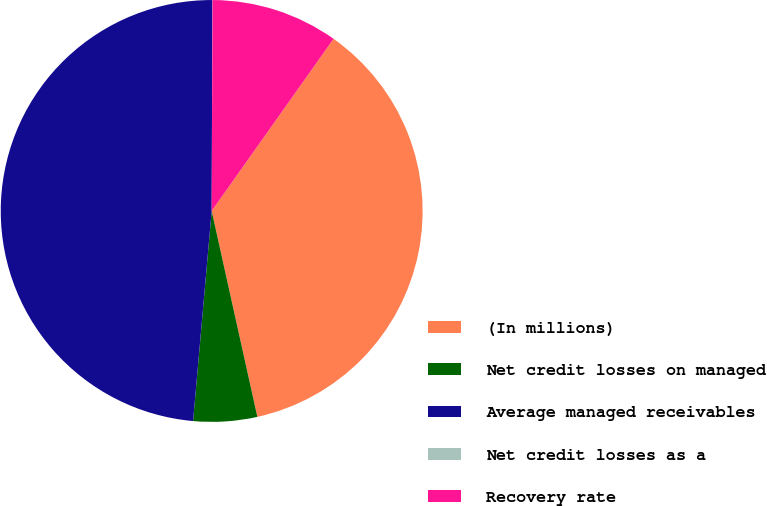Convert chart to OTSL. <chart><loc_0><loc_0><loc_500><loc_500><pie_chart><fcel>(In millions)<fcel>Net credit losses on managed<fcel>Average managed receivables<fcel>Net credit losses as a<fcel>Recovery rate<nl><fcel>36.72%<fcel>4.88%<fcel>48.65%<fcel>0.01%<fcel>9.74%<nl></chart> 